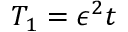Convert formula to latex. <formula><loc_0><loc_0><loc_500><loc_500>T _ { 1 } = \epsilon ^ { 2 } t</formula> 